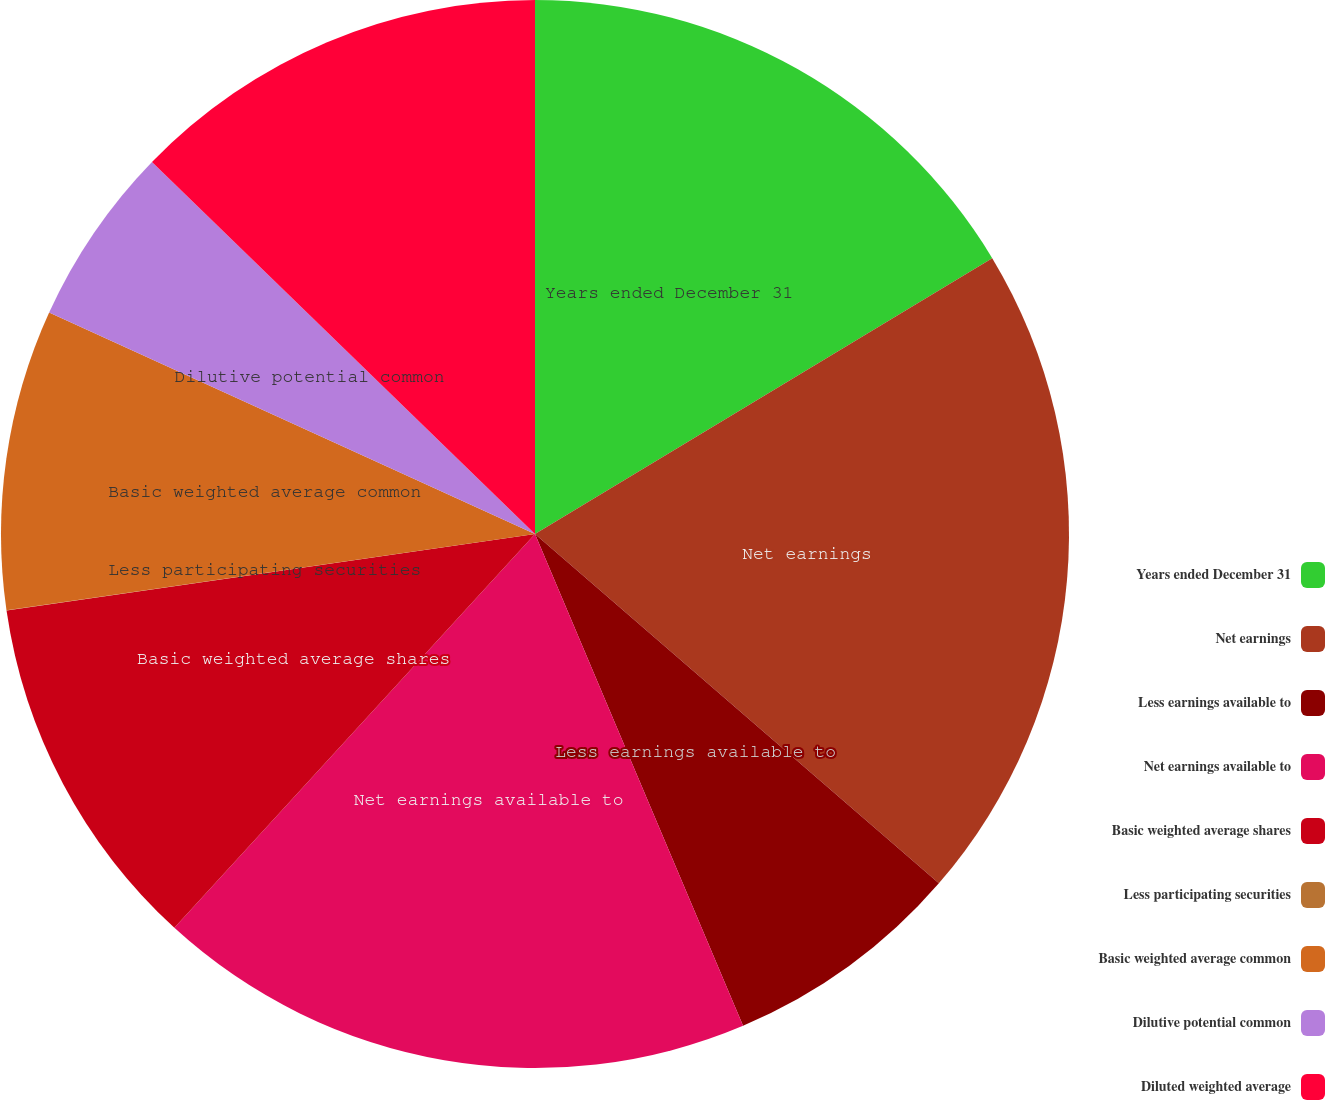Convert chart to OTSL. <chart><loc_0><loc_0><loc_500><loc_500><pie_chart><fcel>Years ended December 31<fcel>Net earnings<fcel>Less earnings available to<fcel>Net earnings available to<fcel>Basic weighted average shares<fcel>Less participating securities<fcel>Basic weighted average common<fcel>Dilutive potential common<fcel>Diluted weighted average<nl><fcel>16.36%<fcel>19.99%<fcel>7.28%<fcel>18.17%<fcel>10.91%<fcel>0.01%<fcel>9.09%<fcel>5.46%<fcel>12.73%<nl></chart> 